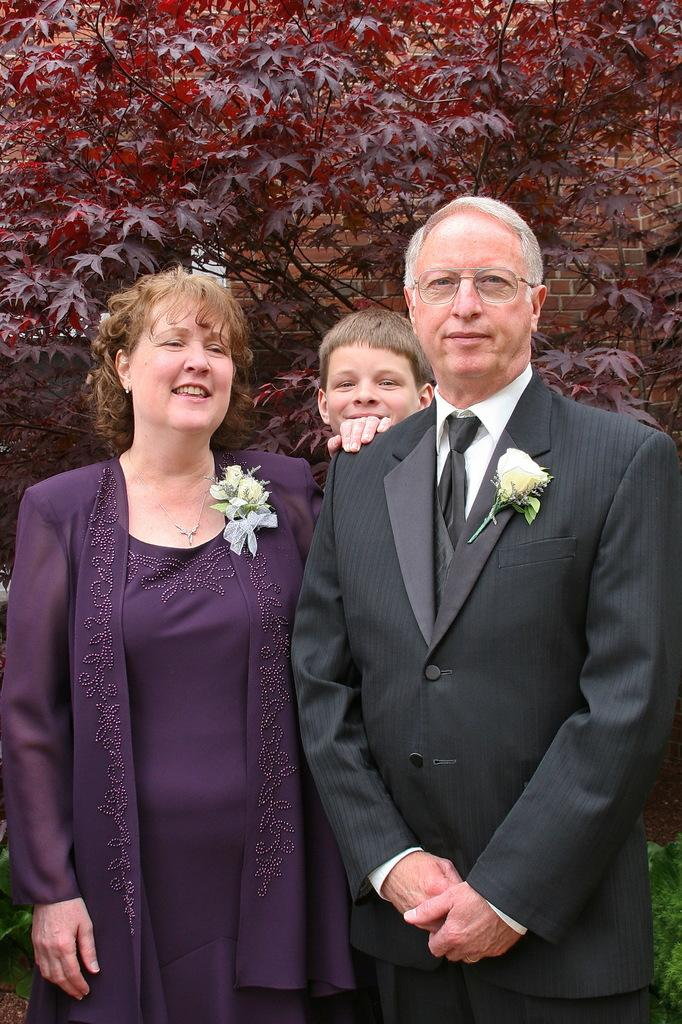How many people are in the image? There are three persons standing in the middle of the image. What are the people doing in the image? The persons are smiling. What can be seen in the background of the image? There are trees visible behind the persons. What type of glove is the person on the left wearing in the image? There is no glove visible on any of the persons in the image. 